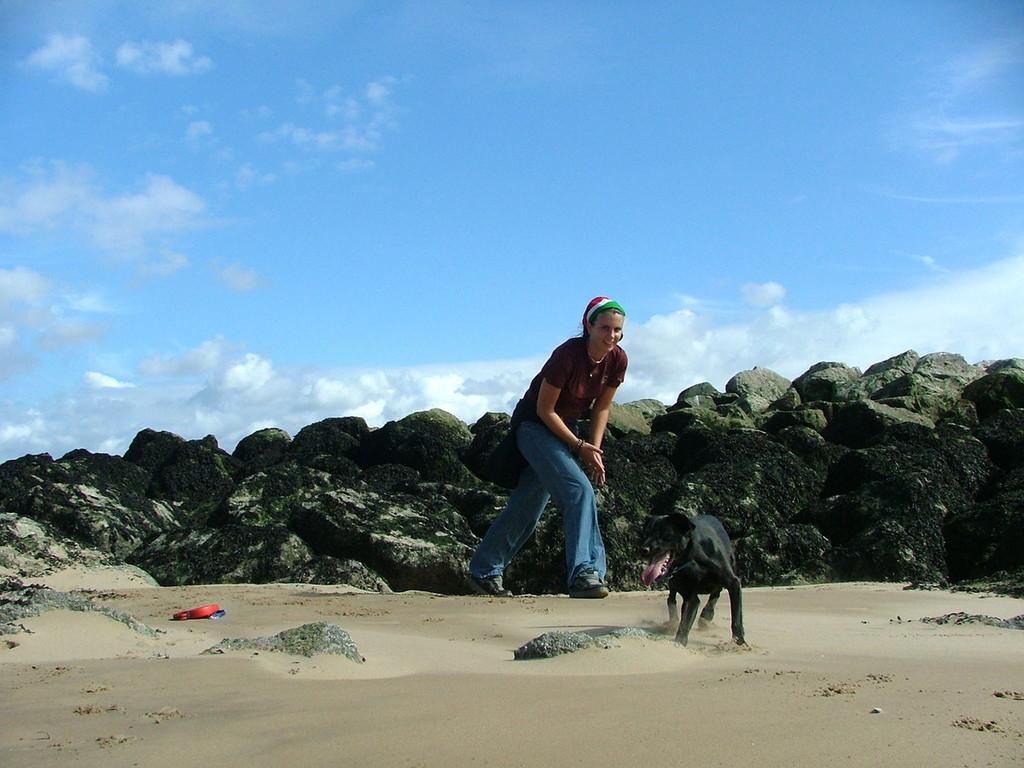What is the woman in the image doing? The woman is running in the image. What type of clothing is the woman wearing? The woman is wearing a t-shirt and trousers. Is there any animal present in the image? Yes, there is a dog in the image. What is the color of the dog? The dog is black in color. What is the color of the sky in the image? The sky is blue in the image. How many wrens can be seen flying in the image? There are no wrens present in the image. What act is the woman performing in the image? The woman is running, which is not an act but an action. 